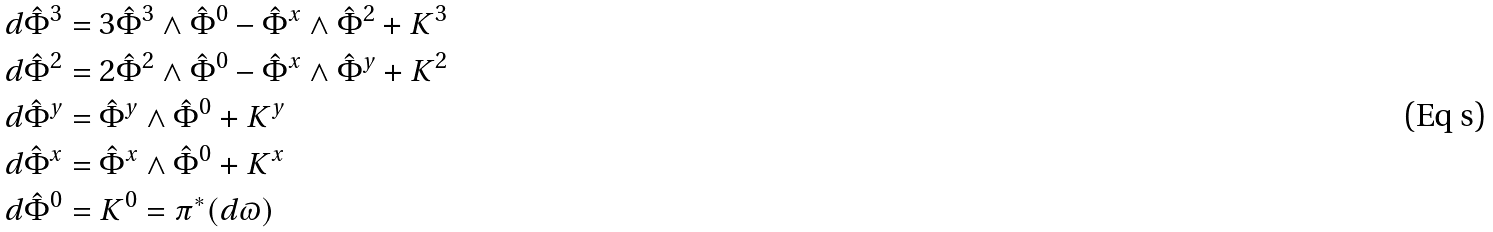Convert formula to latex. <formula><loc_0><loc_0><loc_500><loc_500>d \hat { \Phi } ^ { 3 } & = 3 \hat { \Phi } ^ { 3 } \wedge \hat { \Phi } ^ { 0 } - \hat { \Phi } ^ { x } \wedge \hat { \Phi } ^ { 2 } + K ^ { 3 } \\ d \hat { \Phi } ^ { 2 } & = 2 \hat { \Phi } ^ { 2 } \wedge \hat { \Phi } ^ { 0 } - \hat { \Phi } ^ { x } \wedge \hat { \Phi } ^ { y } + K ^ { 2 } \\ d \hat { \Phi } ^ { y } & = \hat { \Phi } ^ { y } \wedge \hat { \Phi } ^ { 0 } + K ^ { y } \\ d \hat { \Phi } ^ { x } & = \hat { \Phi } ^ { x } \wedge \hat { \Phi } ^ { 0 } + K ^ { x } \\ d \hat { \Phi } ^ { 0 } & = K ^ { 0 } = \pi ^ { * } ( d \varpi )</formula> 